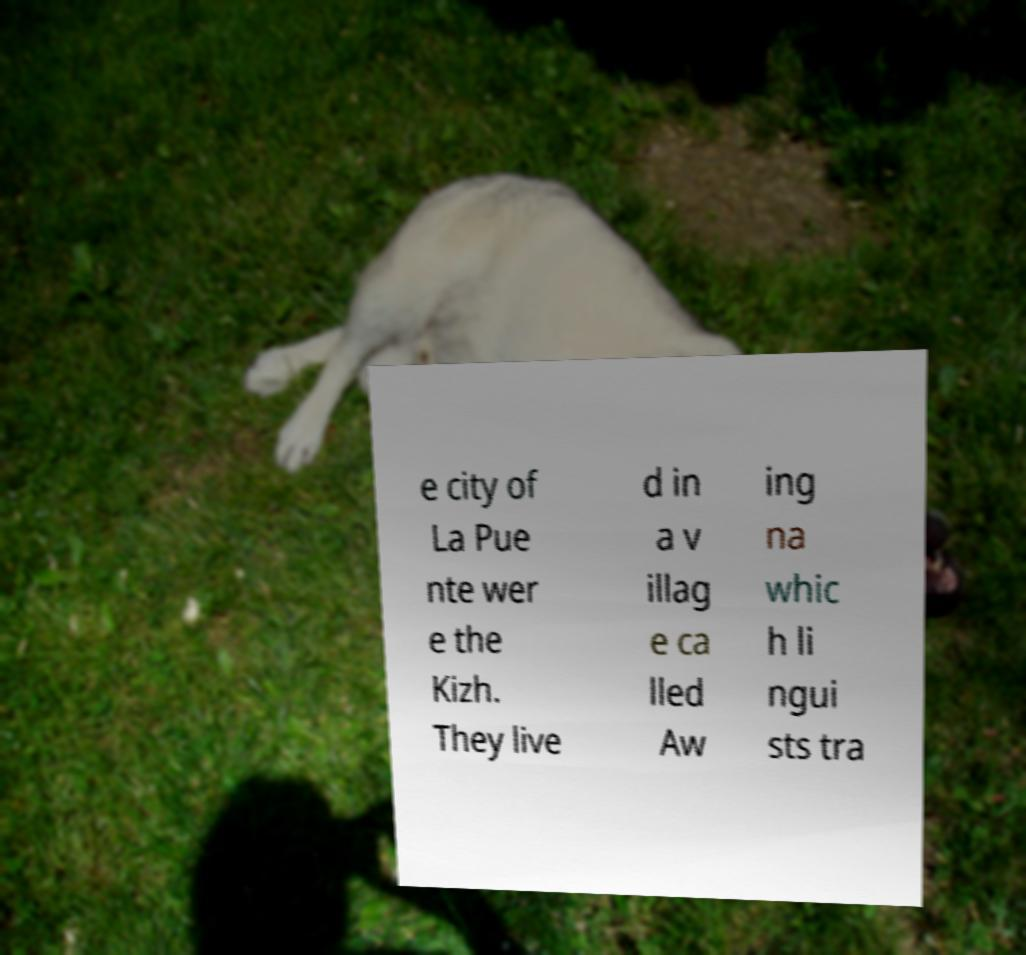Could you extract and type out the text from this image? e city of La Pue nte wer e the Kizh. They live d in a v illag e ca lled Aw ing na whic h li ngui sts tra 